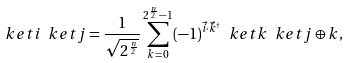<formula> <loc_0><loc_0><loc_500><loc_500>\ k e t { i } \ k e t { j } = \frac { 1 } { \sqrt { 2 ^ { \frac { n } { 2 } } } } \sum _ { k = 0 } ^ { 2 ^ { \frac { n } { 2 } } - 1 } ( - 1 ) ^ { \vec { i } \cdot \vec { k } ^ { \dag } } \ k e t { k } \ k e t { j \oplus k } ,</formula> 